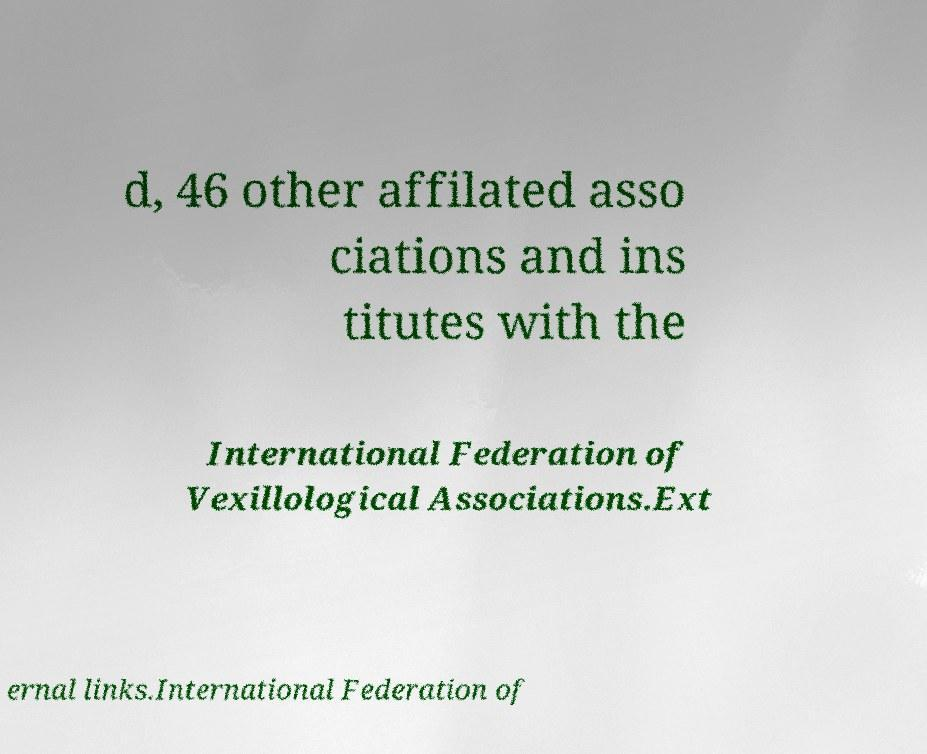Could you assist in decoding the text presented in this image and type it out clearly? d, 46 other affilated asso ciations and ins titutes with the International Federation of Vexillological Associations.Ext ernal links.International Federation of 